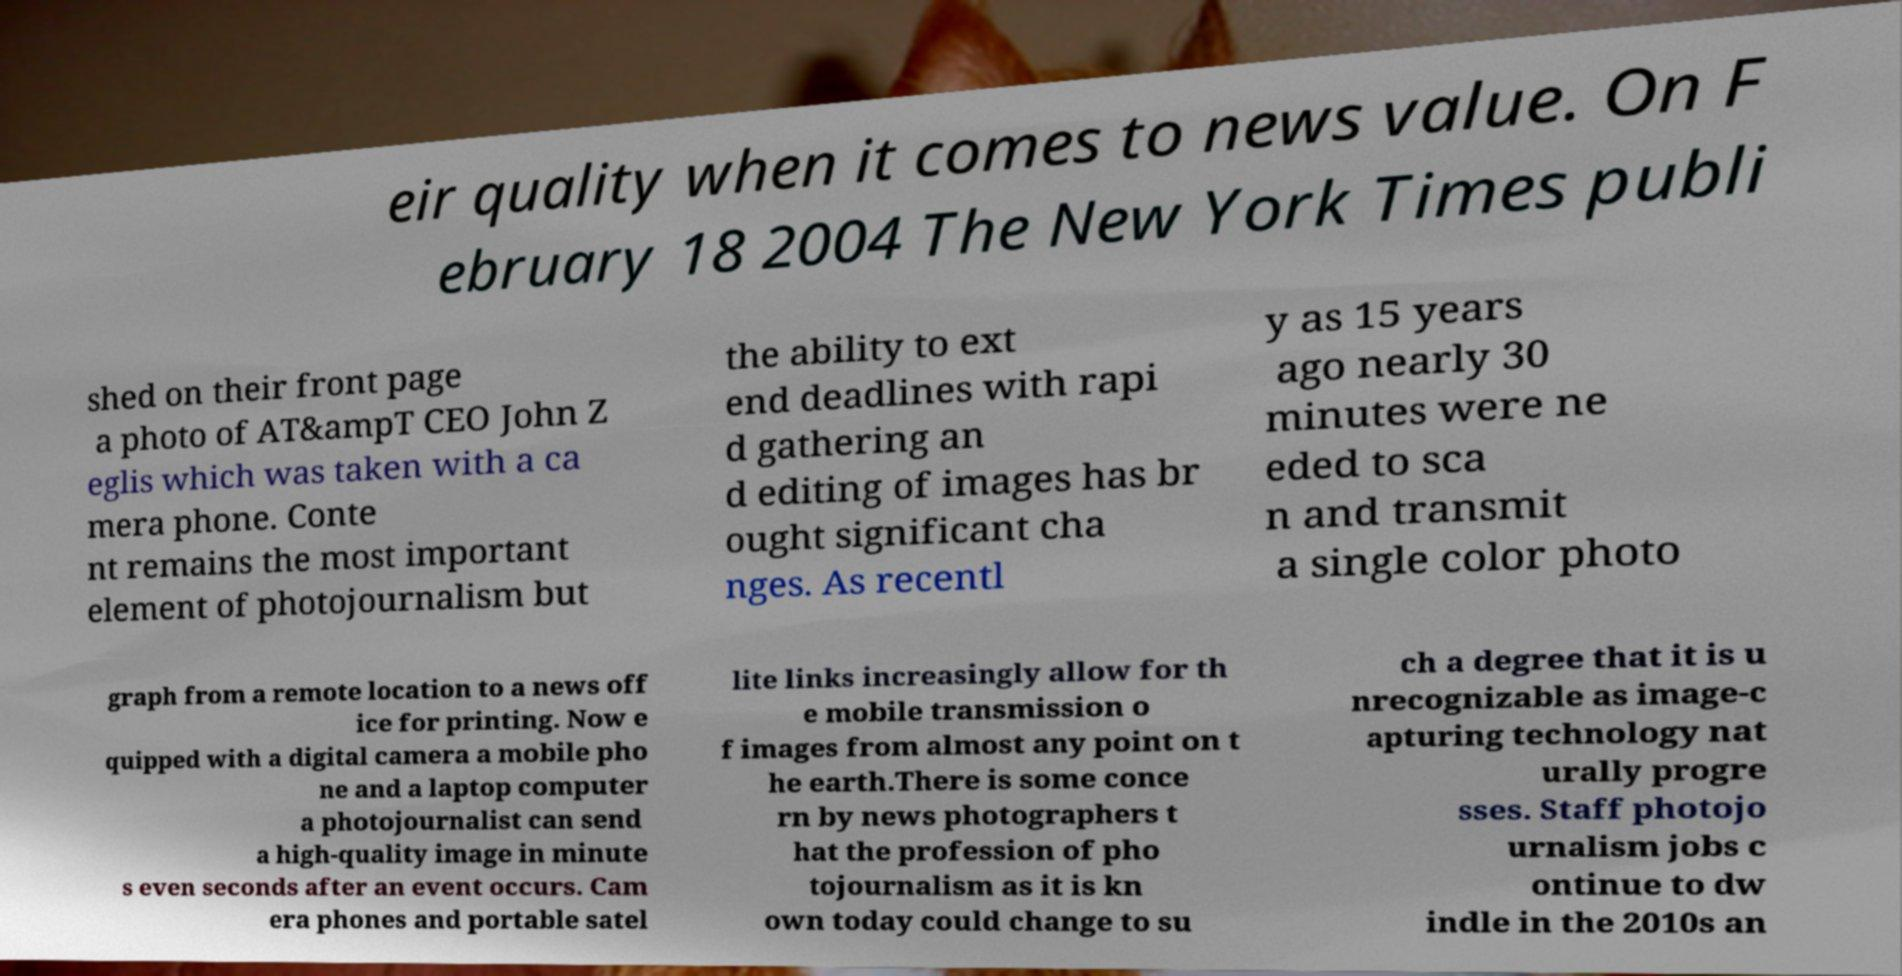I need the written content from this picture converted into text. Can you do that? eir quality when it comes to news value. On F ebruary 18 2004 The New York Times publi shed on their front page a photo of AT&ampT CEO John Z eglis which was taken with a ca mera phone. Conte nt remains the most important element of photojournalism but the ability to ext end deadlines with rapi d gathering an d editing of images has br ought significant cha nges. As recentl y as 15 years ago nearly 30 minutes were ne eded to sca n and transmit a single color photo graph from a remote location to a news off ice for printing. Now e quipped with a digital camera a mobile pho ne and a laptop computer a photojournalist can send a high-quality image in minute s even seconds after an event occurs. Cam era phones and portable satel lite links increasingly allow for th e mobile transmission o f images from almost any point on t he earth.There is some conce rn by news photographers t hat the profession of pho tojournalism as it is kn own today could change to su ch a degree that it is u nrecognizable as image-c apturing technology nat urally progre sses. Staff photojo urnalism jobs c ontinue to dw indle in the 2010s an 